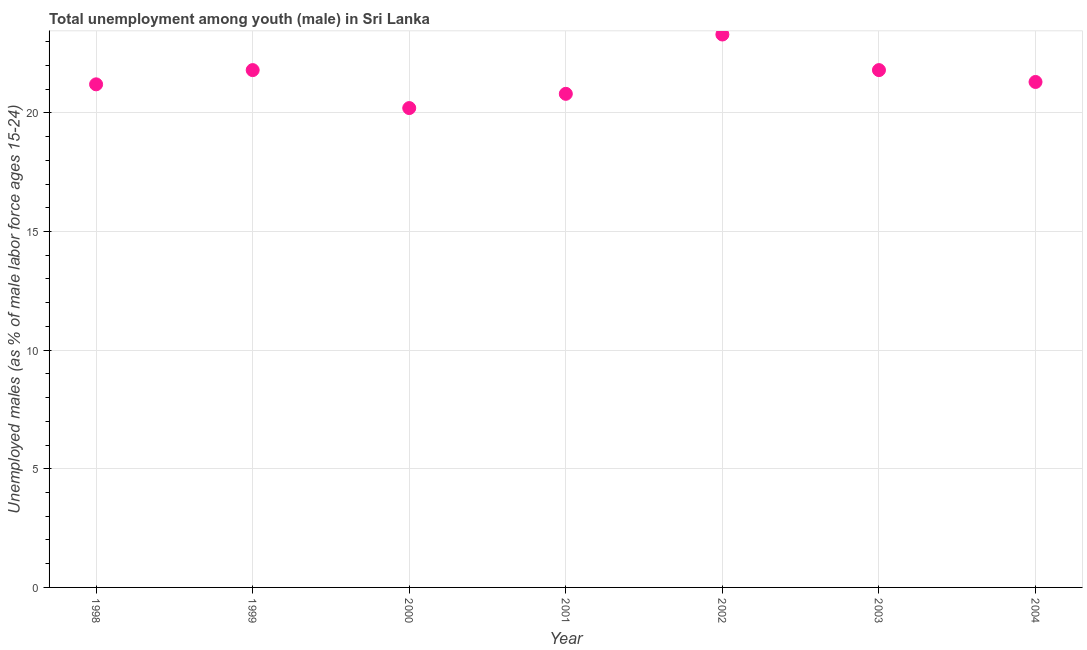What is the unemployed male youth population in 1998?
Provide a succinct answer. 21.2. Across all years, what is the maximum unemployed male youth population?
Offer a very short reply. 23.3. Across all years, what is the minimum unemployed male youth population?
Your answer should be very brief. 20.2. In which year was the unemployed male youth population minimum?
Offer a terse response. 2000. What is the sum of the unemployed male youth population?
Keep it short and to the point. 150.4. What is the difference between the unemployed male youth population in 1998 and 2004?
Provide a short and direct response. -0.1. What is the average unemployed male youth population per year?
Give a very brief answer. 21.49. What is the median unemployed male youth population?
Give a very brief answer. 21.3. Do a majority of the years between 1998 and 2003 (inclusive) have unemployed male youth population greater than 12 %?
Make the answer very short. Yes. What is the ratio of the unemployed male youth population in 2001 to that in 2004?
Keep it short and to the point. 0.98. Is the unemployed male youth population in 2002 less than that in 2003?
Make the answer very short. No. Is the difference between the unemployed male youth population in 1998 and 2002 greater than the difference between any two years?
Make the answer very short. No. What is the difference between the highest and the second highest unemployed male youth population?
Your answer should be very brief. 1.5. Is the sum of the unemployed male youth population in 2001 and 2003 greater than the maximum unemployed male youth population across all years?
Your response must be concise. Yes. What is the difference between the highest and the lowest unemployed male youth population?
Keep it short and to the point. 3.1. In how many years, is the unemployed male youth population greater than the average unemployed male youth population taken over all years?
Provide a short and direct response. 3. What is the difference between two consecutive major ticks on the Y-axis?
Make the answer very short. 5. Are the values on the major ticks of Y-axis written in scientific E-notation?
Provide a succinct answer. No. Does the graph contain any zero values?
Your response must be concise. No. Does the graph contain grids?
Offer a terse response. Yes. What is the title of the graph?
Your response must be concise. Total unemployment among youth (male) in Sri Lanka. What is the label or title of the Y-axis?
Your answer should be compact. Unemployed males (as % of male labor force ages 15-24). What is the Unemployed males (as % of male labor force ages 15-24) in 1998?
Your answer should be compact. 21.2. What is the Unemployed males (as % of male labor force ages 15-24) in 1999?
Offer a terse response. 21.8. What is the Unemployed males (as % of male labor force ages 15-24) in 2000?
Your answer should be very brief. 20.2. What is the Unemployed males (as % of male labor force ages 15-24) in 2001?
Make the answer very short. 20.8. What is the Unemployed males (as % of male labor force ages 15-24) in 2002?
Ensure brevity in your answer.  23.3. What is the Unemployed males (as % of male labor force ages 15-24) in 2003?
Offer a terse response. 21.8. What is the Unemployed males (as % of male labor force ages 15-24) in 2004?
Make the answer very short. 21.3. What is the difference between the Unemployed males (as % of male labor force ages 15-24) in 1998 and 2000?
Provide a succinct answer. 1. What is the difference between the Unemployed males (as % of male labor force ages 15-24) in 1998 and 2002?
Give a very brief answer. -2.1. What is the difference between the Unemployed males (as % of male labor force ages 15-24) in 1999 and 2001?
Ensure brevity in your answer.  1. What is the difference between the Unemployed males (as % of male labor force ages 15-24) in 1999 and 2003?
Your answer should be very brief. 0. What is the difference between the Unemployed males (as % of male labor force ages 15-24) in 2000 and 2001?
Ensure brevity in your answer.  -0.6. What is the difference between the Unemployed males (as % of male labor force ages 15-24) in 2000 and 2002?
Your answer should be compact. -3.1. What is the difference between the Unemployed males (as % of male labor force ages 15-24) in 2000 and 2003?
Make the answer very short. -1.6. What is the difference between the Unemployed males (as % of male labor force ages 15-24) in 2001 and 2004?
Offer a very short reply. -0.5. What is the difference between the Unemployed males (as % of male labor force ages 15-24) in 2002 and 2003?
Ensure brevity in your answer.  1.5. What is the difference between the Unemployed males (as % of male labor force ages 15-24) in 2003 and 2004?
Ensure brevity in your answer.  0.5. What is the ratio of the Unemployed males (as % of male labor force ages 15-24) in 1998 to that in 2000?
Your response must be concise. 1.05. What is the ratio of the Unemployed males (as % of male labor force ages 15-24) in 1998 to that in 2001?
Your answer should be compact. 1.02. What is the ratio of the Unemployed males (as % of male labor force ages 15-24) in 1998 to that in 2002?
Give a very brief answer. 0.91. What is the ratio of the Unemployed males (as % of male labor force ages 15-24) in 1998 to that in 2003?
Make the answer very short. 0.97. What is the ratio of the Unemployed males (as % of male labor force ages 15-24) in 1999 to that in 2000?
Provide a short and direct response. 1.08. What is the ratio of the Unemployed males (as % of male labor force ages 15-24) in 1999 to that in 2001?
Keep it short and to the point. 1.05. What is the ratio of the Unemployed males (as % of male labor force ages 15-24) in 1999 to that in 2002?
Provide a short and direct response. 0.94. What is the ratio of the Unemployed males (as % of male labor force ages 15-24) in 1999 to that in 2003?
Keep it short and to the point. 1. What is the ratio of the Unemployed males (as % of male labor force ages 15-24) in 2000 to that in 2001?
Provide a short and direct response. 0.97. What is the ratio of the Unemployed males (as % of male labor force ages 15-24) in 2000 to that in 2002?
Offer a terse response. 0.87. What is the ratio of the Unemployed males (as % of male labor force ages 15-24) in 2000 to that in 2003?
Your answer should be compact. 0.93. What is the ratio of the Unemployed males (as % of male labor force ages 15-24) in 2000 to that in 2004?
Provide a short and direct response. 0.95. What is the ratio of the Unemployed males (as % of male labor force ages 15-24) in 2001 to that in 2002?
Your answer should be very brief. 0.89. What is the ratio of the Unemployed males (as % of male labor force ages 15-24) in 2001 to that in 2003?
Provide a succinct answer. 0.95. What is the ratio of the Unemployed males (as % of male labor force ages 15-24) in 2001 to that in 2004?
Your answer should be compact. 0.98. What is the ratio of the Unemployed males (as % of male labor force ages 15-24) in 2002 to that in 2003?
Offer a very short reply. 1.07. What is the ratio of the Unemployed males (as % of male labor force ages 15-24) in 2002 to that in 2004?
Provide a short and direct response. 1.09. What is the ratio of the Unemployed males (as % of male labor force ages 15-24) in 2003 to that in 2004?
Offer a terse response. 1.02. 